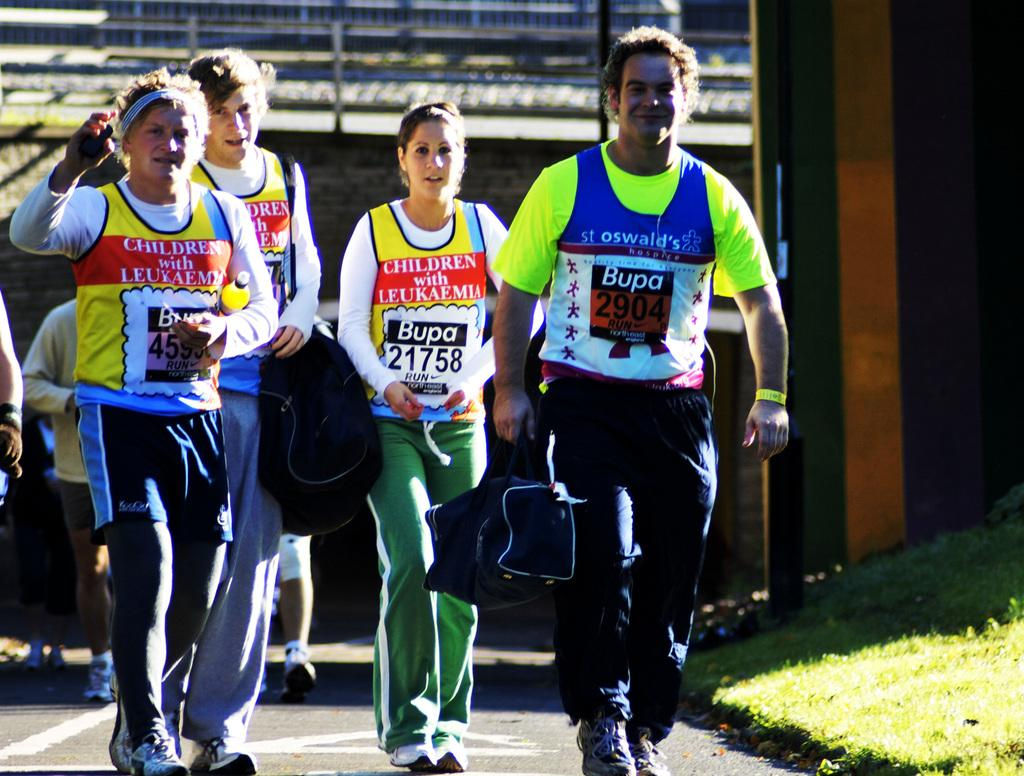<image>
Present a compact description of the photo's key features. Four people are walking down a road wearing Bupa racing bibs. 